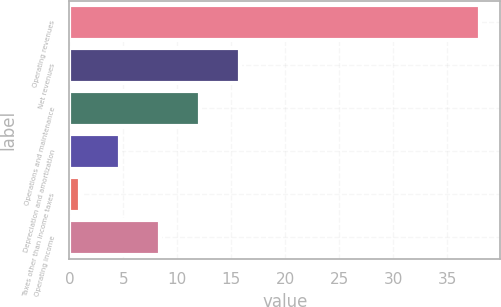<chart> <loc_0><loc_0><loc_500><loc_500><bar_chart><fcel>Operating revenues<fcel>Net revenues<fcel>Operations and maintenance<fcel>Depreciation and amortization<fcel>Taxes other than income taxes<fcel>Operating income<nl><fcel>38<fcel>15.8<fcel>12.1<fcel>4.7<fcel>1<fcel>8.4<nl></chart> 